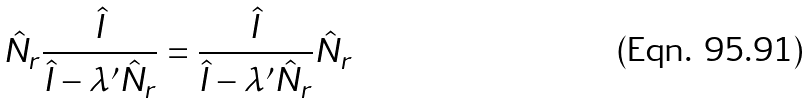Convert formula to latex. <formula><loc_0><loc_0><loc_500><loc_500>\hat { N } _ { r } \frac { \hat { I } } { \hat { I } - \lambda ^ { \prime } \hat { N } _ { r } } = \frac { \hat { I } } { \hat { I } - \lambda ^ { \prime } \hat { N } _ { r } } \hat { N } _ { r }</formula> 